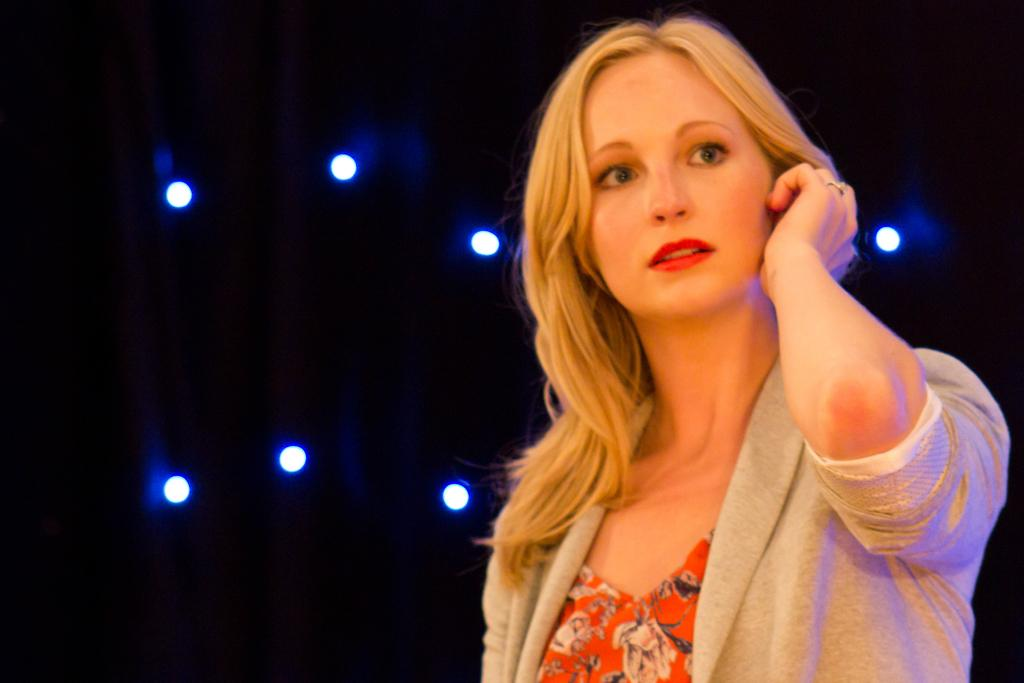Who is the main subject in the image? There is a woman in the image. What is the woman doing in the image? The woman is holding her ear. What is the woman wearing in the image? The woman is wearing a white coat. What can be seen in the background of the image? There are lights visible in the background of the image. What type of vessel is the woman using to hold her ear in the image? There is no vessel present in the image; the woman is simply holding her ear with her hand. 